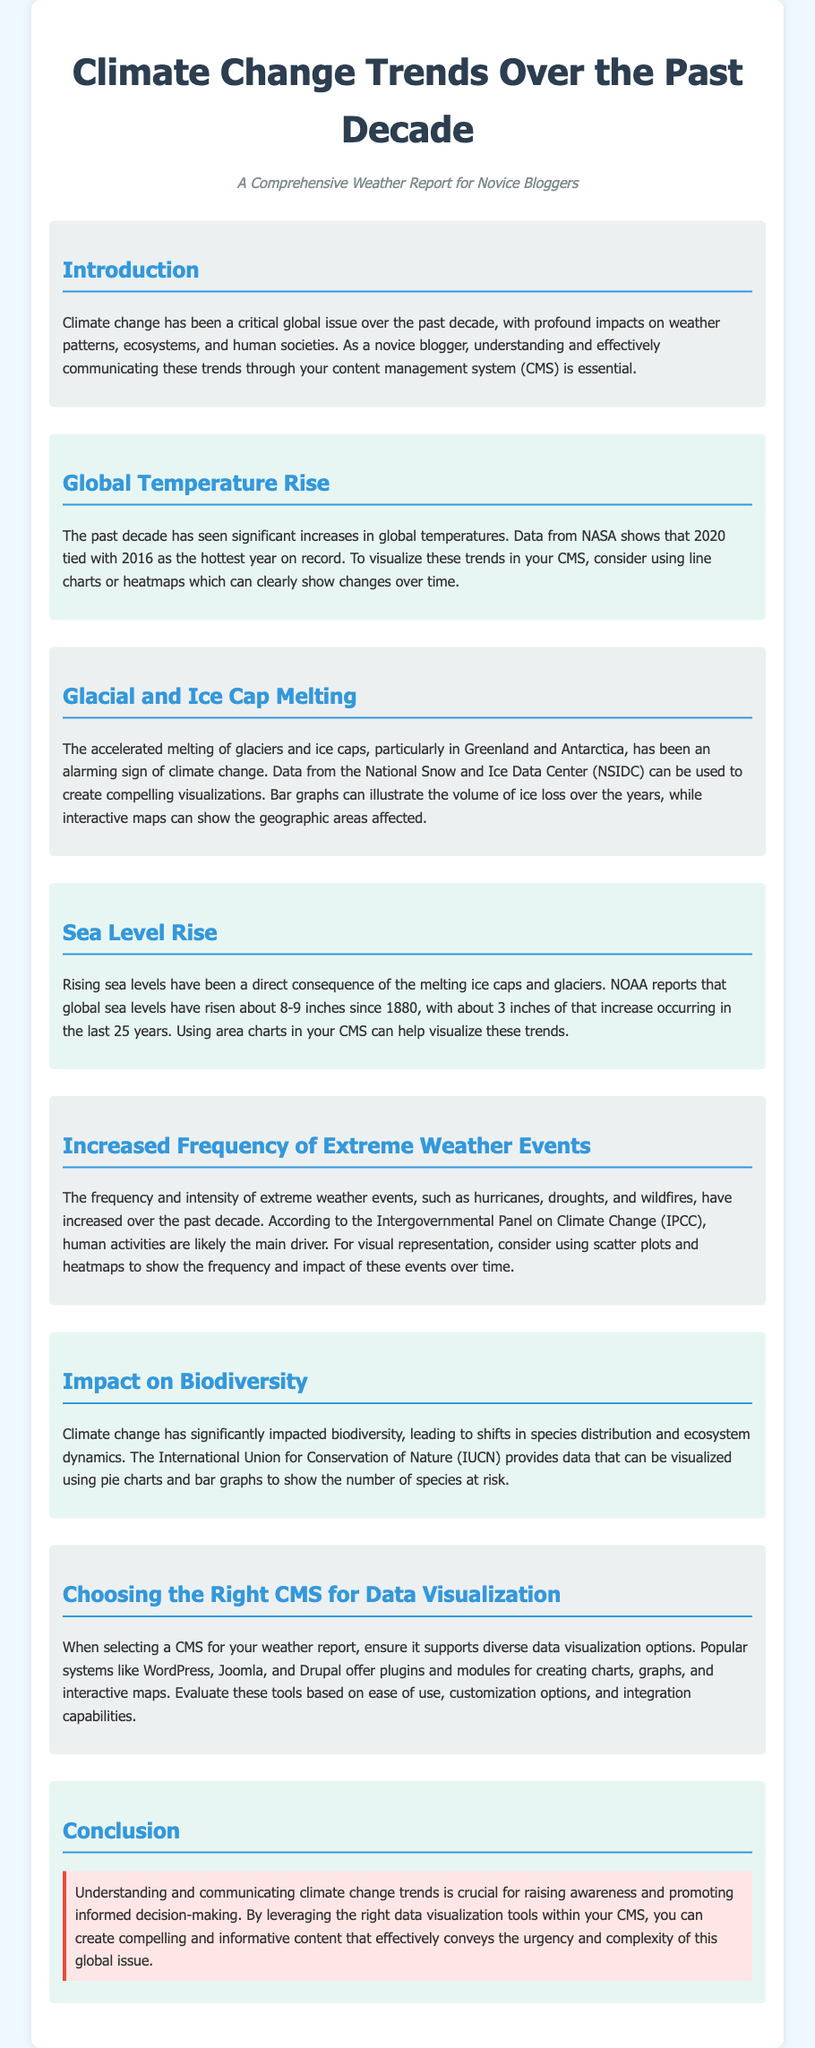what is the title of the document? The title is clearly stated in the document's header, reflecting the main topic discussed.
Answer: Climate Change Trends: A Novice Blogger's Guide which year tied with 2016 as the hottest year on record? The document specifies that 2020 matched 2016 in temperature records, highlighting significant climate trends.
Answer: 2020 what is the increase in global sea levels since 1880? The document provides a specific figure regarding the total rise in global sea levels over this period, indicating significant environmental change.
Answer: 8-9 inches what type of graphs can be used to visualize glacial melting? The document suggests particular types of visualizations that can illustrate changes in ice volume effectively.
Answer: Bar graphs which organization provides data on species at risk due to climate change? The document mentions this organization that tracks biodiversity and conservation status amid climate change effects.
Answer: International Union for Conservation of Nature what are popular CMS options for data visualization? The document lists well-known content management systems that support diverse visualization features for effective presentation.
Answer: WordPress, Joomla, Drupal what visualization tool is suggested for extreme weather events? The text outlines a particular type of graph that is appropriate for showcasing the data associated with these events effectively.
Answer: Scatter plots which decade is discussed regarding climate change trends in the document? The focus of the entire document is on changes and impacts that occurred specifically during this time frame.
Answer: Past decade 